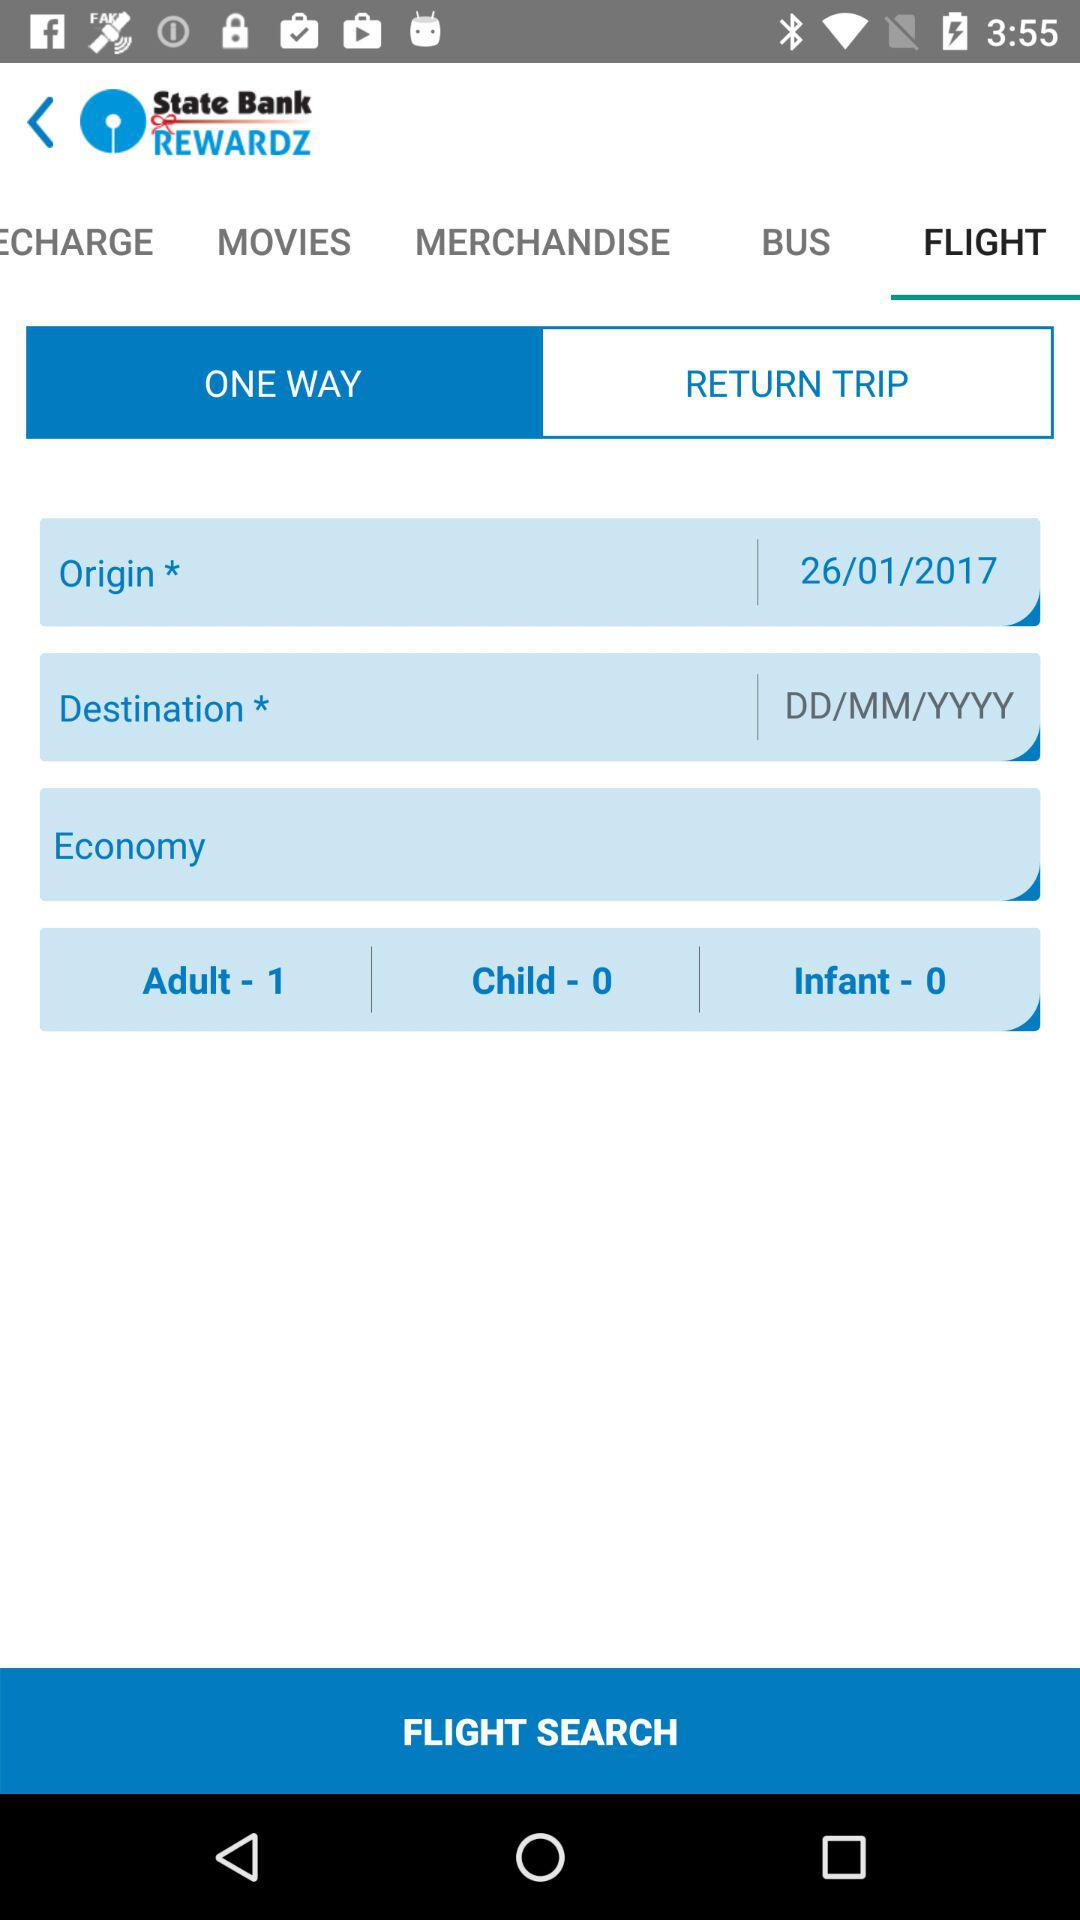How many adults are being searched for?
Answer the question using a single word or phrase. 1 